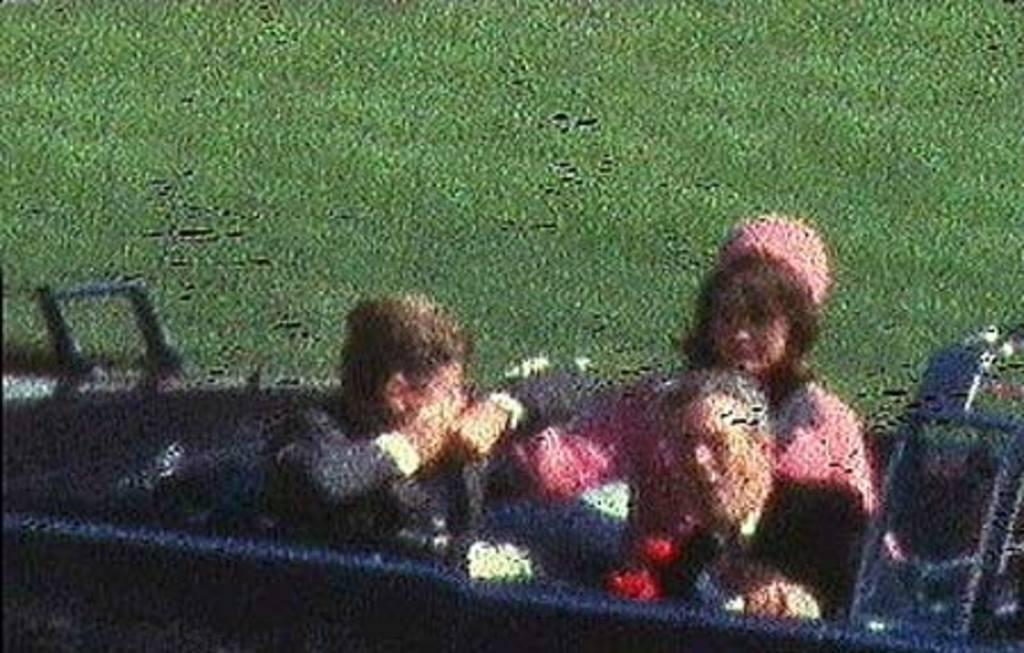What is happening in the image? There are people sitting in a car in the image. Can you describe the position of the people in the car? The facts provided do not specify the position of the people in the car. What type of vehicle is the car in the image? The facts provided do not specify the type of car in the image. What type of nut is being used to power the fan in the image? There is no nut or fan present in the image; it only shows people sitting in a car. 